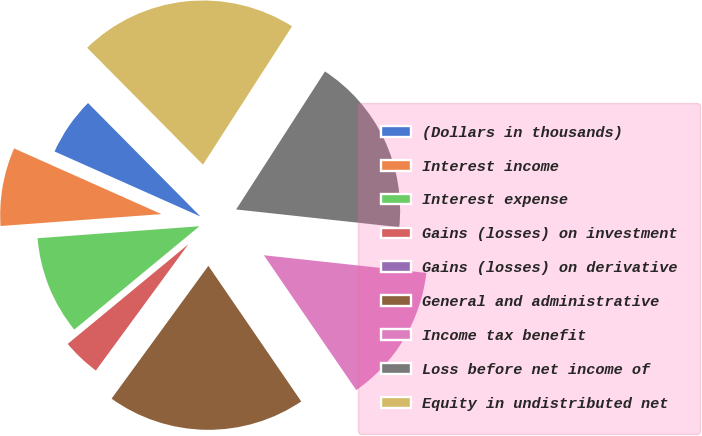Convert chart. <chart><loc_0><loc_0><loc_500><loc_500><pie_chart><fcel>(Dollars in thousands)<fcel>Interest income<fcel>Interest expense<fcel>Gains (losses) on investment<fcel>Gains (losses) on derivative<fcel>General and administrative<fcel>Income tax benefit<fcel>Loss before net income of<fcel>Equity in undistributed net<nl><fcel>5.9%<fcel>7.85%<fcel>9.81%<fcel>3.95%<fcel>0.04%<fcel>19.58%<fcel>13.72%<fcel>17.62%<fcel>21.53%<nl></chart> 